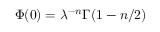Convert formula to latex. <formula><loc_0><loc_0><loc_500><loc_500>\Phi ( 0 ) = \lambda ^ { - n } \Gamma ( 1 - n / 2 )</formula> 